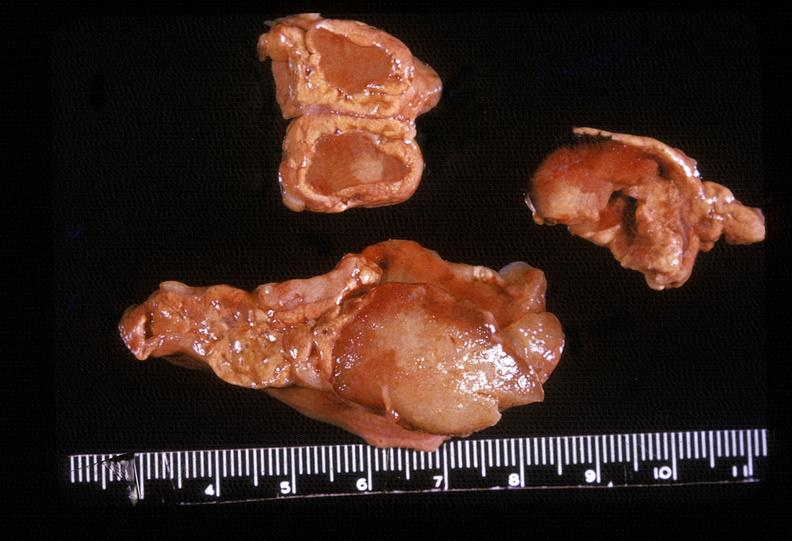what is present?
Answer the question using a single word or phrase. Endocrine 